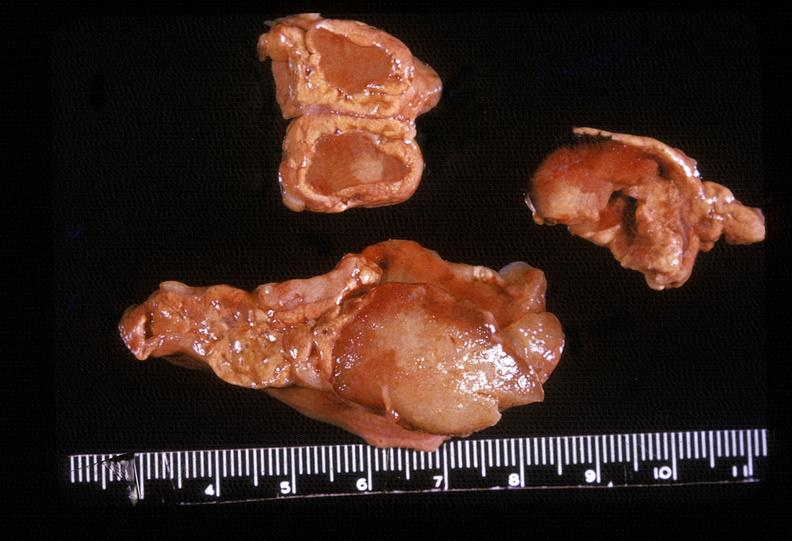what is present?
Answer the question using a single word or phrase. Endocrine 